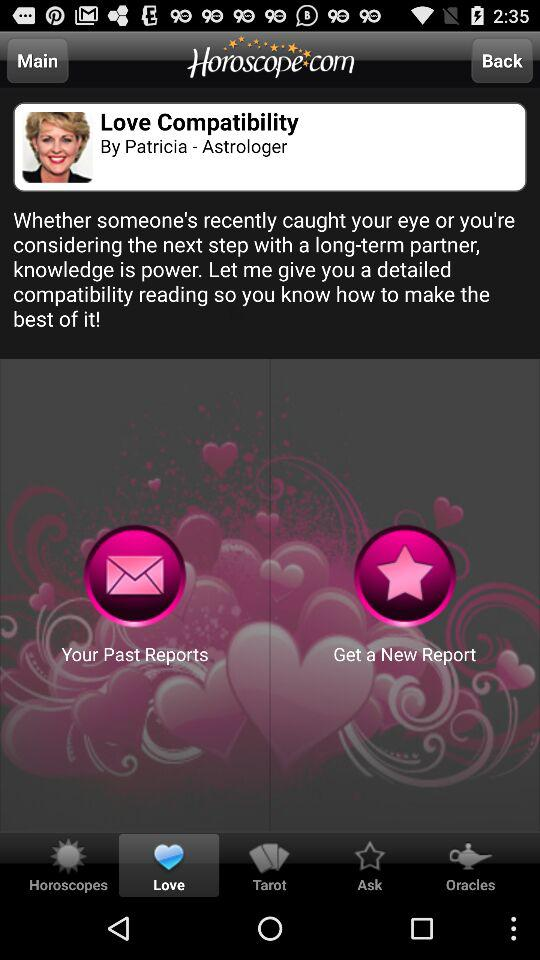What is the developer name? The developer name is "Horoscope.com". 